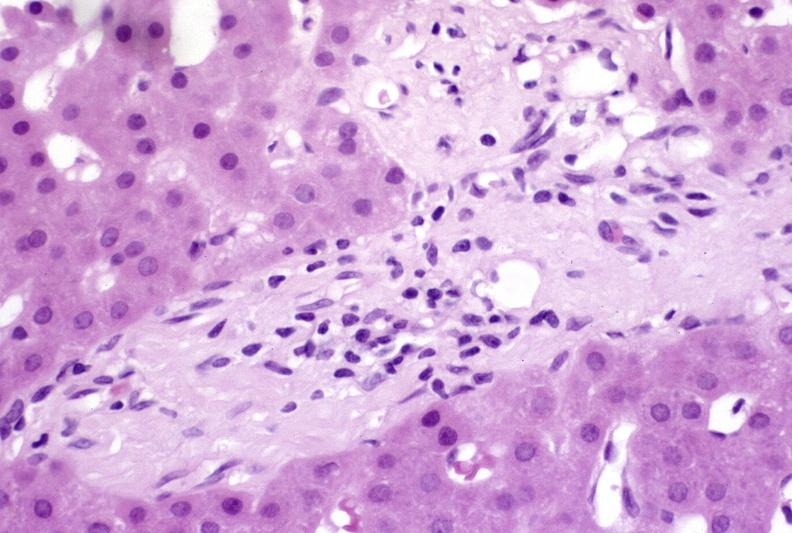s hepatobiliary present?
Answer the question using a single word or phrase. Yes 